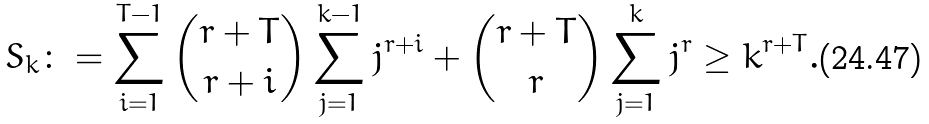<formula> <loc_0><loc_0><loc_500><loc_500>S _ { k } \colon = \sum ^ { T - 1 } _ { i = 1 } \binom { r + T } { r + i } \sum ^ { k - 1 } _ { j = 1 } j ^ { r + i } + \binom { r + T } { r } \sum ^ { k } _ { j = 1 } j ^ { r } \geq k ^ { r + T } .</formula> 